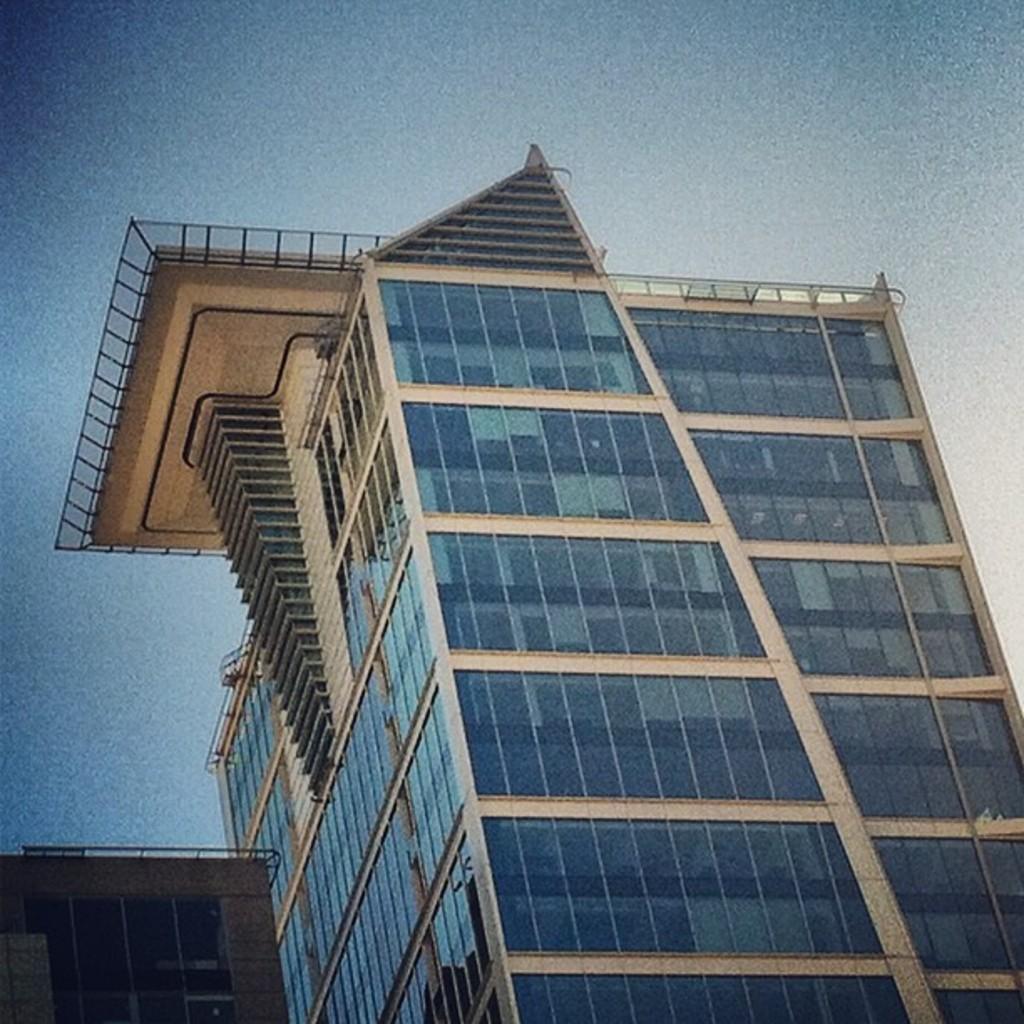Describe this image in one or two sentences. Here I can see two buildings. On the top of the image I can see the sky. 